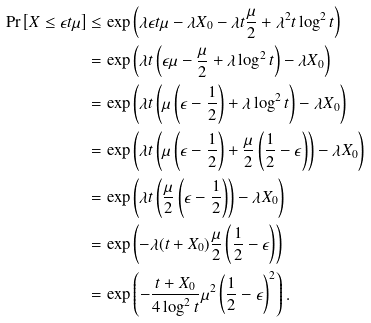Convert formula to latex. <formula><loc_0><loc_0><loc_500><loc_500>\Pr \left [ X \leq \epsilon t \mu \right ] & \leq \exp \left ( \lambda \epsilon t \mu - \lambda X _ { 0 } - \lambda t \frac { \mu } { 2 } + \lambda ^ { 2 } t \log ^ { 2 } t \right ) \\ & = \exp \left ( \lambda t \left ( \epsilon \mu - \frac { \mu } { 2 } + \lambda \log ^ { 2 } t \right ) - \lambda X _ { 0 } \right ) \\ & = \exp \left ( \lambda t \left ( \mu \left ( \epsilon - \frac { 1 } { 2 } \right ) + \lambda \log ^ { 2 } t \right ) - \lambda X _ { 0 } \right ) \\ & = \exp \left ( \lambda t \left ( \mu \left ( \epsilon - \frac { 1 } { 2 } \right ) + \frac { \mu } { 2 } \left ( \frac { 1 } { 2 } - \epsilon \right ) \right ) - \lambda X _ { 0 } \right ) \\ & = \exp \left ( \lambda t \left ( \frac { \mu } { 2 } \left ( \epsilon - \frac { 1 } { 2 } \right ) \right ) - \lambda X _ { 0 } \right ) \\ & = \exp \left ( - \lambda ( t + X _ { 0 } ) \frac { \mu } { 2 } \left ( \frac { 1 } { 2 } - \epsilon \right ) \right ) \\ & = \exp \left ( - \frac { t + X _ { 0 } } { 4 \log ^ { 2 } t } \mu ^ { 2 } \left ( \frac { 1 } { 2 } - \epsilon \right ) ^ { 2 } \right ) .</formula> 